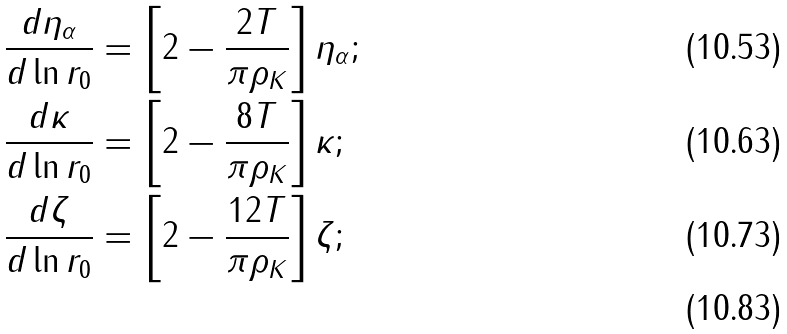Convert formula to latex. <formula><loc_0><loc_0><loc_500><loc_500>& \frac { d \eta _ { \alpha } } { d \ln r _ { 0 } } = \left [ 2 - \frac { 2 T } { \pi \rho _ { K } } \right ] \eta _ { \alpha } ; \\ & \frac { d \kappa } { d \ln r _ { 0 } } = \left [ 2 - \frac { 8 T } { \pi \rho _ { K } } \right ] \kappa ; \\ & \frac { d \zeta } { d \ln r _ { 0 } } = \left [ 2 - \frac { 1 2 T } { \pi \rho _ { K } } \right ] \zeta ; \\</formula> 